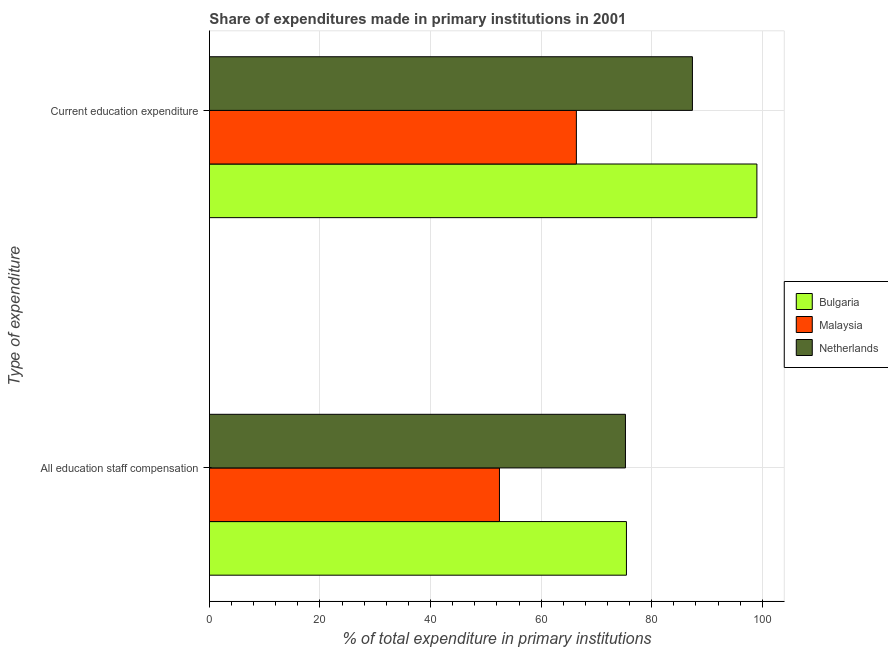How many different coloured bars are there?
Offer a terse response. 3. How many groups of bars are there?
Provide a short and direct response. 2. Are the number of bars on each tick of the Y-axis equal?
Keep it short and to the point. Yes. How many bars are there on the 2nd tick from the top?
Give a very brief answer. 3. How many bars are there on the 2nd tick from the bottom?
Give a very brief answer. 3. What is the label of the 1st group of bars from the top?
Give a very brief answer. Current education expenditure. What is the expenditure in education in Netherlands?
Offer a terse response. 87.36. Across all countries, what is the maximum expenditure in education?
Keep it short and to the point. 99.02. Across all countries, what is the minimum expenditure in staff compensation?
Offer a very short reply. 52.46. In which country was the expenditure in education minimum?
Make the answer very short. Malaysia. What is the total expenditure in staff compensation in the graph?
Provide a succinct answer. 203.13. What is the difference between the expenditure in staff compensation in Malaysia and that in Bulgaria?
Your answer should be compact. -22.97. What is the difference between the expenditure in education in Malaysia and the expenditure in staff compensation in Netherlands?
Your response must be concise. -8.87. What is the average expenditure in education per country?
Ensure brevity in your answer.  84.25. What is the difference between the expenditure in education and expenditure in staff compensation in Netherlands?
Your answer should be very brief. 12.12. What is the ratio of the expenditure in education in Netherlands to that in Malaysia?
Offer a terse response. 1.32. In how many countries, is the expenditure in staff compensation greater than the average expenditure in staff compensation taken over all countries?
Provide a short and direct response. 2. What does the 2nd bar from the bottom in Current education expenditure represents?
Ensure brevity in your answer.  Malaysia. Are all the bars in the graph horizontal?
Offer a terse response. Yes. How many countries are there in the graph?
Ensure brevity in your answer.  3. Does the graph contain any zero values?
Provide a succinct answer. No. Does the graph contain grids?
Make the answer very short. Yes. What is the title of the graph?
Your response must be concise. Share of expenditures made in primary institutions in 2001. Does "Central Europe" appear as one of the legend labels in the graph?
Ensure brevity in your answer.  No. What is the label or title of the X-axis?
Offer a terse response. % of total expenditure in primary institutions. What is the label or title of the Y-axis?
Your answer should be very brief. Type of expenditure. What is the % of total expenditure in primary institutions of Bulgaria in All education staff compensation?
Provide a succinct answer. 75.43. What is the % of total expenditure in primary institutions of Malaysia in All education staff compensation?
Ensure brevity in your answer.  52.46. What is the % of total expenditure in primary institutions in Netherlands in All education staff compensation?
Provide a succinct answer. 75.25. What is the % of total expenditure in primary institutions of Bulgaria in Current education expenditure?
Offer a terse response. 99.02. What is the % of total expenditure in primary institutions of Malaysia in Current education expenditure?
Provide a succinct answer. 66.37. What is the % of total expenditure in primary institutions in Netherlands in Current education expenditure?
Give a very brief answer. 87.36. Across all Type of expenditure, what is the maximum % of total expenditure in primary institutions in Bulgaria?
Keep it short and to the point. 99.02. Across all Type of expenditure, what is the maximum % of total expenditure in primary institutions of Malaysia?
Offer a very short reply. 66.37. Across all Type of expenditure, what is the maximum % of total expenditure in primary institutions in Netherlands?
Your response must be concise. 87.36. Across all Type of expenditure, what is the minimum % of total expenditure in primary institutions in Bulgaria?
Offer a terse response. 75.43. Across all Type of expenditure, what is the minimum % of total expenditure in primary institutions in Malaysia?
Offer a very short reply. 52.46. Across all Type of expenditure, what is the minimum % of total expenditure in primary institutions of Netherlands?
Offer a very short reply. 75.25. What is the total % of total expenditure in primary institutions of Bulgaria in the graph?
Make the answer very short. 174.45. What is the total % of total expenditure in primary institutions in Malaysia in the graph?
Provide a succinct answer. 118.83. What is the total % of total expenditure in primary institutions of Netherlands in the graph?
Give a very brief answer. 162.61. What is the difference between the % of total expenditure in primary institutions of Bulgaria in All education staff compensation and that in Current education expenditure?
Provide a short and direct response. -23.6. What is the difference between the % of total expenditure in primary institutions of Malaysia in All education staff compensation and that in Current education expenditure?
Your response must be concise. -13.91. What is the difference between the % of total expenditure in primary institutions of Netherlands in All education staff compensation and that in Current education expenditure?
Offer a terse response. -12.12. What is the difference between the % of total expenditure in primary institutions of Bulgaria in All education staff compensation and the % of total expenditure in primary institutions of Malaysia in Current education expenditure?
Offer a very short reply. 9.05. What is the difference between the % of total expenditure in primary institutions in Bulgaria in All education staff compensation and the % of total expenditure in primary institutions in Netherlands in Current education expenditure?
Offer a very short reply. -11.94. What is the difference between the % of total expenditure in primary institutions of Malaysia in All education staff compensation and the % of total expenditure in primary institutions of Netherlands in Current education expenditure?
Offer a very short reply. -34.91. What is the average % of total expenditure in primary institutions in Bulgaria per Type of expenditure?
Provide a succinct answer. 87.22. What is the average % of total expenditure in primary institutions in Malaysia per Type of expenditure?
Keep it short and to the point. 59.42. What is the average % of total expenditure in primary institutions of Netherlands per Type of expenditure?
Ensure brevity in your answer.  81.31. What is the difference between the % of total expenditure in primary institutions of Bulgaria and % of total expenditure in primary institutions of Malaysia in All education staff compensation?
Ensure brevity in your answer.  22.97. What is the difference between the % of total expenditure in primary institutions of Bulgaria and % of total expenditure in primary institutions of Netherlands in All education staff compensation?
Your answer should be compact. 0.18. What is the difference between the % of total expenditure in primary institutions of Malaysia and % of total expenditure in primary institutions of Netherlands in All education staff compensation?
Offer a very short reply. -22.79. What is the difference between the % of total expenditure in primary institutions of Bulgaria and % of total expenditure in primary institutions of Malaysia in Current education expenditure?
Keep it short and to the point. 32.65. What is the difference between the % of total expenditure in primary institutions of Bulgaria and % of total expenditure in primary institutions of Netherlands in Current education expenditure?
Give a very brief answer. 11.66. What is the difference between the % of total expenditure in primary institutions in Malaysia and % of total expenditure in primary institutions in Netherlands in Current education expenditure?
Make the answer very short. -20.99. What is the ratio of the % of total expenditure in primary institutions of Bulgaria in All education staff compensation to that in Current education expenditure?
Provide a short and direct response. 0.76. What is the ratio of the % of total expenditure in primary institutions in Malaysia in All education staff compensation to that in Current education expenditure?
Make the answer very short. 0.79. What is the ratio of the % of total expenditure in primary institutions in Netherlands in All education staff compensation to that in Current education expenditure?
Your answer should be compact. 0.86. What is the difference between the highest and the second highest % of total expenditure in primary institutions in Bulgaria?
Your answer should be very brief. 23.6. What is the difference between the highest and the second highest % of total expenditure in primary institutions of Malaysia?
Ensure brevity in your answer.  13.91. What is the difference between the highest and the second highest % of total expenditure in primary institutions in Netherlands?
Your answer should be compact. 12.12. What is the difference between the highest and the lowest % of total expenditure in primary institutions of Bulgaria?
Offer a very short reply. 23.6. What is the difference between the highest and the lowest % of total expenditure in primary institutions in Malaysia?
Ensure brevity in your answer.  13.91. What is the difference between the highest and the lowest % of total expenditure in primary institutions in Netherlands?
Give a very brief answer. 12.12. 